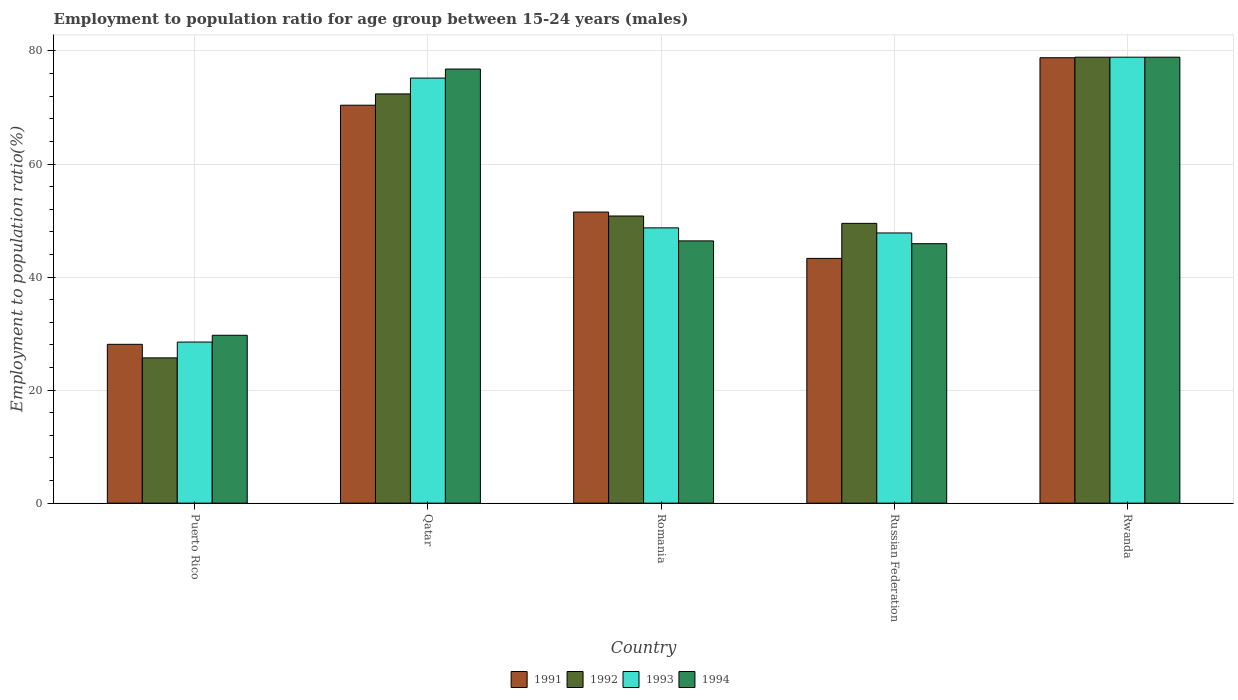How many different coloured bars are there?
Ensure brevity in your answer.  4. How many groups of bars are there?
Ensure brevity in your answer.  5. Are the number of bars per tick equal to the number of legend labels?
Offer a terse response. Yes. Are the number of bars on each tick of the X-axis equal?
Make the answer very short. Yes. How many bars are there on the 2nd tick from the right?
Give a very brief answer. 4. What is the label of the 4th group of bars from the left?
Ensure brevity in your answer.  Russian Federation. In how many cases, is the number of bars for a given country not equal to the number of legend labels?
Ensure brevity in your answer.  0. What is the employment to population ratio in 1991 in Russian Federation?
Ensure brevity in your answer.  43.3. Across all countries, what is the maximum employment to population ratio in 1994?
Offer a very short reply. 78.9. Across all countries, what is the minimum employment to population ratio in 1993?
Offer a very short reply. 28.5. In which country was the employment to population ratio in 1994 maximum?
Offer a very short reply. Rwanda. In which country was the employment to population ratio in 1992 minimum?
Give a very brief answer. Puerto Rico. What is the total employment to population ratio in 1992 in the graph?
Your answer should be very brief. 277.3. What is the difference between the employment to population ratio in 1992 in Russian Federation and that in Rwanda?
Offer a very short reply. -29.4. What is the difference between the employment to population ratio in 1994 in Romania and the employment to population ratio in 1992 in Russian Federation?
Ensure brevity in your answer.  -3.1. What is the average employment to population ratio in 1991 per country?
Provide a short and direct response. 54.42. What is the difference between the employment to population ratio of/in 1993 and employment to population ratio of/in 1994 in Qatar?
Offer a terse response. -1.6. What is the ratio of the employment to population ratio in 1991 in Puerto Rico to that in Romania?
Keep it short and to the point. 0.55. Is the employment to population ratio in 1992 in Romania less than that in Rwanda?
Your answer should be very brief. Yes. Is the difference between the employment to population ratio in 1993 in Qatar and Romania greater than the difference between the employment to population ratio in 1994 in Qatar and Romania?
Make the answer very short. No. What is the difference between the highest and the second highest employment to population ratio in 1993?
Make the answer very short. -26.5. What is the difference between the highest and the lowest employment to population ratio in 1991?
Ensure brevity in your answer.  50.7. Is it the case that in every country, the sum of the employment to population ratio in 1992 and employment to population ratio in 1993 is greater than the sum of employment to population ratio in 1994 and employment to population ratio in 1991?
Give a very brief answer. No. Is it the case that in every country, the sum of the employment to population ratio in 1992 and employment to population ratio in 1993 is greater than the employment to population ratio in 1994?
Make the answer very short. Yes. How many countries are there in the graph?
Keep it short and to the point. 5. What is the difference between two consecutive major ticks on the Y-axis?
Your response must be concise. 20. Are the values on the major ticks of Y-axis written in scientific E-notation?
Keep it short and to the point. No. How many legend labels are there?
Provide a succinct answer. 4. How are the legend labels stacked?
Your response must be concise. Horizontal. What is the title of the graph?
Offer a very short reply. Employment to population ratio for age group between 15-24 years (males). Does "1998" appear as one of the legend labels in the graph?
Offer a terse response. No. What is the label or title of the X-axis?
Keep it short and to the point. Country. What is the label or title of the Y-axis?
Ensure brevity in your answer.  Employment to population ratio(%). What is the Employment to population ratio(%) in 1991 in Puerto Rico?
Make the answer very short. 28.1. What is the Employment to population ratio(%) of 1992 in Puerto Rico?
Provide a succinct answer. 25.7. What is the Employment to population ratio(%) in 1993 in Puerto Rico?
Offer a very short reply. 28.5. What is the Employment to population ratio(%) of 1994 in Puerto Rico?
Give a very brief answer. 29.7. What is the Employment to population ratio(%) of 1991 in Qatar?
Offer a very short reply. 70.4. What is the Employment to population ratio(%) in 1992 in Qatar?
Keep it short and to the point. 72.4. What is the Employment to population ratio(%) in 1993 in Qatar?
Provide a succinct answer. 75.2. What is the Employment to population ratio(%) of 1994 in Qatar?
Your response must be concise. 76.8. What is the Employment to population ratio(%) of 1991 in Romania?
Offer a terse response. 51.5. What is the Employment to population ratio(%) of 1992 in Romania?
Make the answer very short. 50.8. What is the Employment to population ratio(%) in 1993 in Romania?
Your response must be concise. 48.7. What is the Employment to population ratio(%) of 1994 in Romania?
Offer a very short reply. 46.4. What is the Employment to population ratio(%) of 1991 in Russian Federation?
Offer a terse response. 43.3. What is the Employment to population ratio(%) in 1992 in Russian Federation?
Your answer should be compact. 49.5. What is the Employment to population ratio(%) in 1993 in Russian Federation?
Keep it short and to the point. 47.8. What is the Employment to population ratio(%) of 1994 in Russian Federation?
Keep it short and to the point. 45.9. What is the Employment to population ratio(%) in 1991 in Rwanda?
Offer a very short reply. 78.8. What is the Employment to population ratio(%) of 1992 in Rwanda?
Offer a terse response. 78.9. What is the Employment to population ratio(%) of 1993 in Rwanda?
Provide a succinct answer. 78.9. What is the Employment to population ratio(%) of 1994 in Rwanda?
Your answer should be very brief. 78.9. Across all countries, what is the maximum Employment to population ratio(%) of 1991?
Ensure brevity in your answer.  78.8. Across all countries, what is the maximum Employment to population ratio(%) in 1992?
Your answer should be very brief. 78.9. Across all countries, what is the maximum Employment to population ratio(%) of 1993?
Your answer should be very brief. 78.9. Across all countries, what is the maximum Employment to population ratio(%) of 1994?
Give a very brief answer. 78.9. Across all countries, what is the minimum Employment to population ratio(%) in 1991?
Ensure brevity in your answer.  28.1. Across all countries, what is the minimum Employment to population ratio(%) in 1992?
Your response must be concise. 25.7. Across all countries, what is the minimum Employment to population ratio(%) in 1993?
Your response must be concise. 28.5. Across all countries, what is the minimum Employment to population ratio(%) of 1994?
Your answer should be very brief. 29.7. What is the total Employment to population ratio(%) in 1991 in the graph?
Your answer should be compact. 272.1. What is the total Employment to population ratio(%) in 1992 in the graph?
Make the answer very short. 277.3. What is the total Employment to population ratio(%) in 1993 in the graph?
Give a very brief answer. 279.1. What is the total Employment to population ratio(%) of 1994 in the graph?
Offer a very short reply. 277.7. What is the difference between the Employment to population ratio(%) of 1991 in Puerto Rico and that in Qatar?
Your answer should be compact. -42.3. What is the difference between the Employment to population ratio(%) of 1992 in Puerto Rico and that in Qatar?
Offer a terse response. -46.7. What is the difference between the Employment to population ratio(%) of 1993 in Puerto Rico and that in Qatar?
Your answer should be compact. -46.7. What is the difference between the Employment to population ratio(%) of 1994 in Puerto Rico and that in Qatar?
Make the answer very short. -47.1. What is the difference between the Employment to population ratio(%) in 1991 in Puerto Rico and that in Romania?
Your answer should be compact. -23.4. What is the difference between the Employment to population ratio(%) of 1992 in Puerto Rico and that in Romania?
Give a very brief answer. -25.1. What is the difference between the Employment to population ratio(%) in 1993 in Puerto Rico and that in Romania?
Your answer should be compact. -20.2. What is the difference between the Employment to population ratio(%) of 1994 in Puerto Rico and that in Romania?
Offer a very short reply. -16.7. What is the difference between the Employment to population ratio(%) in 1991 in Puerto Rico and that in Russian Federation?
Ensure brevity in your answer.  -15.2. What is the difference between the Employment to population ratio(%) in 1992 in Puerto Rico and that in Russian Federation?
Your answer should be compact. -23.8. What is the difference between the Employment to population ratio(%) of 1993 in Puerto Rico and that in Russian Federation?
Your answer should be compact. -19.3. What is the difference between the Employment to population ratio(%) in 1994 in Puerto Rico and that in Russian Federation?
Your answer should be compact. -16.2. What is the difference between the Employment to population ratio(%) of 1991 in Puerto Rico and that in Rwanda?
Ensure brevity in your answer.  -50.7. What is the difference between the Employment to population ratio(%) of 1992 in Puerto Rico and that in Rwanda?
Give a very brief answer. -53.2. What is the difference between the Employment to population ratio(%) of 1993 in Puerto Rico and that in Rwanda?
Give a very brief answer. -50.4. What is the difference between the Employment to population ratio(%) in 1994 in Puerto Rico and that in Rwanda?
Make the answer very short. -49.2. What is the difference between the Employment to population ratio(%) of 1992 in Qatar and that in Romania?
Your answer should be compact. 21.6. What is the difference between the Employment to population ratio(%) of 1993 in Qatar and that in Romania?
Offer a very short reply. 26.5. What is the difference between the Employment to population ratio(%) of 1994 in Qatar and that in Romania?
Ensure brevity in your answer.  30.4. What is the difference between the Employment to population ratio(%) of 1991 in Qatar and that in Russian Federation?
Your answer should be very brief. 27.1. What is the difference between the Employment to population ratio(%) of 1992 in Qatar and that in Russian Federation?
Your answer should be very brief. 22.9. What is the difference between the Employment to population ratio(%) in 1993 in Qatar and that in Russian Federation?
Keep it short and to the point. 27.4. What is the difference between the Employment to population ratio(%) in 1994 in Qatar and that in Russian Federation?
Provide a succinct answer. 30.9. What is the difference between the Employment to population ratio(%) of 1991 in Romania and that in Rwanda?
Your response must be concise. -27.3. What is the difference between the Employment to population ratio(%) of 1992 in Romania and that in Rwanda?
Your answer should be very brief. -28.1. What is the difference between the Employment to population ratio(%) of 1993 in Romania and that in Rwanda?
Make the answer very short. -30.2. What is the difference between the Employment to population ratio(%) of 1994 in Romania and that in Rwanda?
Keep it short and to the point. -32.5. What is the difference between the Employment to population ratio(%) of 1991 in Russian Federation and that in Rwanda?
Ensure brevity in your answer.  -35.5. What is the difference between the Employment to population ratio(%) of 1992 in Russian Federation and that in Rwanda?
Offer a very short reply. -29.4. What is the difference between the Employment to population ratio(%) in 1993 in Russian Federation and that in Rwanda?
Your response must be concise. -31.1. What is the difference between the Employment to population ratio(%) of 1994 in Russian Federation and that in Rwanda?
Make the answer very short. -33. What is the difference between the Employment to population ratio(%) in 1991 in Puerto Rico and the Employment to population ratio(%) in 1992 in Qatar?
Give a very brief answer. -44.3. What is the difference between the Employment to population ratio(%) of 1991 in Puerto Rico and the Employment to population ratio(%) of 1993 in Qatar?
Offer a very short reply. -47.1. What is the difference between the Employment to population ratio(%) of 1991 in Puerto Rico and the Employment to population ratio(%) of 1994 in Qatar?
Provide a short and direct response. -48.7. What is the difference between the Employment to population ratio(%) in 1992 in Puerto Rico and the Employment to population ratio(%) in 1993 in Qatar?
Your answer should be compact. -49.5. What is the difference between the Employment to population ratio(%) in 1992 in Puerto Rico and the Employment to population ratio(%) in 1994 in Qatar?
Offer a very short reply. -51.1. What is the difference between the Employment to population ratio(%) of 1993 in Puerto Rico and the Employment to population ratio(%) of 1994 in Qatar?
Provide a succinct answer. -48.3. What is the difference between the Employment to population ratio(%) of 1991 in Puerto Rico and the Employment to population ratio(%) of 1992 in Romania?
Provide a succinct answer. -22.7. What is the difference between the Employment to population ratio(%) of 1991 in Puerto Rico and the Employment to population ratio(%) of 1993 in Romania?
Your answer should be compact. -20.6. What is the difference between the Employment to population ratio(%) in 1991 in Puerto Rico and the Employment to population ratio(%) in 1994 in Romania?
Your response must be concise. -18.3. What is the difference between the Employment to population ratio(%) in 1992 in Puerto Rico and the Employment to population ratio(%) in 1994 in Romania?
Keep it short and to the point. -20.7. What is the difference between the Employment to population ratio(%) of 1993 in Puerto Rico and the Employment to population ratio(%) of 1994 in Romania?
Give a very brief answer. -17.9. What is the difference between the Employment to population ratio(%) of 1991 in Puerto Rico and the Employment to population ratio(%) of 1992 in Russian Federation?
Keep it short and to the point. -21.4. What is the difference between the Employment to population ratio(%) in 1991 in Puerto Rico and the Employment to population ratio(%) in 1993 in Russian Federation?
Make the answer very short. -19.7. What is the difference between the Employment to population ratio(%) of 1991 in Puerto Rico and the Employment to population ratio(%) of 1994 in Russian Federation?
Give a very brief answer. -17.8. What is the difference between the Employment to population ratio(%) in 1992 in Puerto Rico and the Employment to population ratio(%) in 1993 in Russian Federation?
Give a very brief answer. -22.1. What is the difference between the Employment to population ratio(%) of 1992 in Puerto Rico and the Employment to population ratio(%) of 1994 in Russian Federation?
Your response must be concise. -20.2. What is the difference between the Employment to population ratio(%) of 1993 in Puerto Rico and the Employment to population ratio(%) of 1994 in Russian Federation?
Give a very brief answer. -17.4. What is the difference between the Employment to population ratio(%) in 1991 in Puerto Rico and the Employment to population ratio(%) in 1992 in Rwanda?
Your response must be concise. -50.8. What is the difference between the Employment to population ratio(%) in 1991 in Puerto Rico and the Employment to population ratio(%) in 1993 in Rwanda?
Your response must be concise. -50.8. What is the difference between the Employment to population ratio(%) of 1991 in Puerto Rico and the Employment to population ratio(%) of 1994 in Rwanda?
Offer a very short reply. -50.8. What is the difference between the Employment to population ratio(%) of 1992 in Puerto Rico and the Employment to population ratio(%) of 1993 in Rwanda?
Offer a terse response. -53.2. What is the difference between the Employment to population ratio(%) in 1992 in Puerto Rico and the Employment to population ratio(%) in 1994 in Rwanda?
Ensure brevity in your answer.  -53.2. What is the difference between the Employment to population ratio(%) of 1993 in Puerto Rico and the Employment to population ratio(%) of 1994 in Rwanda?
Provide a succinct answer. -50.4. What is the difference between the Employment to population ratio(%) in 1991 in Qatar and the Employment to population ratio(%) in 1992 in Romania?
Provide a short and direct response. 19.6. What is the difference between the Employment to population ratio(%) in 1991 in Qatar and the Employment to population ratio(%) in 1993 in Romania?
Your response must be concise. 21.7. What is the difference between the Employment to population ratio(%) of 1991 in Qatar and the Employment to population ratio(%) of 1994 in Romania?
Ensure brevity in your answer.  24. What is the difference between the Employment to population ratio(%) of 1992 in Qatar and the Employment to population ratio(%) of 1993 in Romania?
Your answer should be very brief. 23.7. What is the difference between the Employment to population ratio(%) in 1993 in Qatar and the Employment to population ratio(%) in 1994 in Romania?
Provide a short and direct response. 28.8. What is the difference between the Employment to population ratio(%) of 1991 in Qatar and the Employment to population ratio(%) of 1992 in Russian Federation?
Provide a succinct answer. 20.9. What is the difference between the Employment to population ratio(%) of 1991 in Qatar and the Employment to population ratio(%) of 1993 in Russian Federation?
Keep it short and to the point. 22.6. What is the difference between the Employment to population ratio(%) in 1991 in Qatar and the Employment to population ratio(%) in 1994 in Russian Federation?
Your answer should be very brief. 24.5. What is the difference between the Employment to population ratio(%) in 1992 in Qatar and the Employment to population ratio(%) in 1993 in Russian Federation?
Ensure brevity in your answer.  24.6. What is the difference between the Employment to population ratio(%) of 1993 in Qatar and the Employment to population ratio(%) of 1994 in Russian Federation?
Provide a short and direct response. 29.3. What is the difference between the Employment to population ratio(%) in 1991 in Qatar and the Employment to population ratio(%) in 1992 in Rwanda?
Offer a very short reply. -8.5. What is the difference between the Employment to population ratio(%) in 1991 in Qatar and the Employment to population ratio(%) in 1993 in Rwanda?
Your answer should be very brief. -8.5. What is the difference between the Employment to population ratio(%) in 1992 in Qatar and the Employment to population ratio(%) in 1993 in Rwanda?
Ensure brevity in your answer.  -6.5. What is the difference between the Employment to population ratio(%) in 1992 in Qatar and the Employment to population ratio(%) in 1994 in Rwanda?
Provide a succinct answer. -6.5. What is the difference between the Employment to population ratio(%) of 1993 in Qatar and the Employment to population ratio(%) of 1994 in Rwanda?
Your response must be concise. -3.7. What is the difference between the Employment to population ratio(%) in 1991 in Romania and the Employment to population ratio(%) in 1992 in Rwanda?
Provide a succinct answer. -27.4. What is the difference between the Employment to population ratio(%) of 1991 in Romania and the Employment to population ratio(%) of 1993 in Rwanda?
Offer a terse response. -27.4. What is the difference between the Employment to population ratio(%) of 1991 in Romania and the Employment to population ratio(%) of 1994 in Rwanda?
Your answer should be very brief. -27.4. What is the difference between the Employment to population ratio(%) of 1992 in Romania and the Employment to population ratio(%) of 1993 in Rwanda?
Keep it short and to the point. -28.1. What is the difference between the Employment to population ratio(%) in 1992 in Romania and the Employment to population ratio(%) in 1994 in Rwanda?
Your answer should be compact. -28.1. What is the difference between the Employment to population ratio(%) of 1993 in Romania and the Employment to population ratio(%) of 1994 in Rwanda?
Offer a terse response. -30.2. What is the difference between the Employment to population ratio(%) of 1991 in Russian Federation and the Employment to population ratio(%) of 1992 in Rwanda?
Offer a terse response. -35.6. What is the difference between the Employment to population ratio(%) in 1991 in Russian Federation and the Employment to population ratio(%) in 1993 in Rwanda?
Offer a very short reply. -35.6. What is the difference between the Employment to population ratio(%) in 1991 in Russian Federation and the Employment to population ratio(%) in 1994 in Rwanda?
Your answer should be compact. -35.6. What is the difference between the Employment to population ratio(%) of 1992 in Russian Federation and the Employment to population ratio(%) of 1993 in Rwanda?
Ensure brevity in your answer.  -29.4. What is the difference between the Employment to population ratio(%) of 1992 in Russian Federation and the Employment to population ratio(%) of 1994 in Rwanda?
Offer a very short reply. -29.4. What is the difference between the Employment to population ratio(%) of 1993 in Russian Federation and the Employment to population ratio(%) of 1994 in Rwanda?
Ensure brevity in your answer.  -31.1. What is the average Employment to population ratio(%) in 1991 per country?
Your answer should be very brief. 54.42. What is the average Employment to population ratio(%) in 1992 per country?
Your answer should be compact. 55.46. What is the average Employment to population ratio(%) of 1993 per country?
Your answer should be compact. 55.82. What is the average Employment to population ratio(%) in 1994 per country?
Provide a short and direct response. 55.54. What is the difference between the Employment to population ratio(%) of 1992 and Employment to population ratio(%) of 1994 in Puerto Rico?
Ensure brevity in your answer.  -4. What is the difference between the Employment to population ratio(%) in 1991 and Employment to population ratio(%) in 1992 in Qatar?
Give a very brief answer. -2. What is the difference between the Employment to population ratio(%) of 1991 and Employment to population ratio(%) of 1993 in Qatar?
Your answer should be compact. -4.8. What is the difference between the Employment to population ratio(%) of 1992 and Employment to population ratio(%) of 1994 in Qatar?
Keep it short and to the point. -4.4. What is the difference between the Employment to population ratio(%) of 1991 and Employment to population ratio(%) of 1992 in Romania?
Your response must be concise. 0.7. What is the difference between the Employment to population ratio(%) of 1991 and Employment to population ratio(%) of 1993 in Romania?
Give a very brief answer. 2.8. What is the difference between the Employment to population ratio(%) in 1992 and Employment to population ratio(%) in 1993 in Romania?
Ensure brevity in your answer.  2.1. What is the difference between the Employment to population ratio(%) in 1992 and Employment to population ratio(%) in 1994 in Russian Federation?
Your response must be concise. 3.6. What is the difference between the Employment to population ratio(%) in 1993 and Employment to population ratio(%) in 1994 in Russian Federation?
Provide a short and direct response. 1.9. What is the difference between the Employment to population ratio(%) in 1991 and Employment to population ratio(%) in 1992 in Rwanda?
Your answer should be compact. -0.1. What is the difference between the Employment to population ratio(%) in 1992 and Employment to population ratio(%) in 1993 in Rwanda?
Provide a succinct answer. 0. What is the difference between the Employment to population ratio(%) of 1992 and Employment to population ratio(%) of 1994 in Rwanda?
Offer a terse response. 0. What is the difference between the Employment to population ratio(%) in 1993 and Employment to population ratio(%) in 1994 in Rwanda?
Offer a terse response. 0. What is the ratio of the Employment to population ratio(%) in 1991 in Puerto Rico to that in Qatar?
Your response must be concise. 0.4. What is the ratio of the Employment to population ratio(%) of 1992 in Puerto Rico to that in Qatar?
Ensure brevity in your answer.  0.35. What is the ratio of the Employment to population ratio(%) in 1993 in Puerto Rico to that in Qatar?
Make the answer very short. 0.38. What is the ratio of the Employment to population ratio(%) of 1994 in Puerto Rico to that in Qatar?
Your answer should be very brief. 0.39. What is the ratio of the Employment to population ratio(%) of 1991 in Puerto Rico to that in Romania?
Make the answer very short. 0.55. What is the ratio of the Employment to population ratio(%) in 1992 in Puerto Rico to that in Romania?
Offer a terse response. 0.51. What is the ratio of the Employment to population ratio(%) in 1993 in Puerto Rico to that in Romania?
Ensure brevity in your answer.  0.59. What is the ratio of the Employment to population ratio(%) of 1994 in Puerto Rico to that in Romania?
Your answer should be compact. 0.64. What is the ratio of the Employment to population ratio(%) of 1991 in Puerto Rico to that in Russian Federation?
Give a very brief answer. 0.65. What is the ratio of the Employment to population ratio(%) of 1992 in Puerto Rico to that in Russian Federation?
Offer a terse response. 0.52. What is the ratio of the Employment to population ratio(%) in 1993 in Puerto Rico to that in Russian Federation?
Ensure brevity in your answer.  0.6. What is the ratio of the Employment to population ratio(%) of 1994 in Puerto Rico to that in Russian Federation?
Your response must be concise. 0.65. What is the ratio of the Employment to population ratio(%) in 1991 in Puerto Rico to that in Rwanda?
Provide a short and direct response. 0.36. What is the ratio of the Employment to population ratio(%) in 1992 in Puerto Rico to that in Rwanda?
Ensure brevity in your answer.  0.33. What is the ratio of the Employment to population ratio(%) in 1993 in Puerto Rico to that in Rwanda?
Ensure brevity in your answer.  0.36. What is the ratio of the Employment to population ratio(%) of 1994 in Puerto Rico to that in Rwanda?
Provide a succinct answer. 0.38. What is the ratio of the Employment to population ratio(%) in 1991 in Qatar to that in Romania?
Offer a very short reply. 1.37. What is the ratio of the Employment to population ratio(%) of 1992 in Qatar to that in Romania?
Ensure brevity in your answer.  1.43. What is the ratio of the Employment to population ratio(%) in 1993 in Qatar to that in Romania?
Your response must be concise. 1.54. What is the ratio of the Employment to population ratio(%) in 1994 in Qatar to that in Romania?
Ensure brevity in your answer.  1.66. What is the ratio of the Employment to population ratio(%) in 1991 in Qatar to that in Russian Federation?
Provide a short and direct response. 1.63. What is the ratio of the Employment to population ratio(%) of 1992 in Qatar to that in Russian Federation?
Offer a very short reply. 1.46. What is the ratio of the Employment to population ratio(%) of 1993 in Qatar to that in Russian Federation?
Your answer should be very brief. 1.57. What is the ratio of the Employment to population ratio(%) of 1994 in Qatar to that in Russian Federation?
Keep it short and to the point. 1.67. What is the ratio of the Employment to population ratio(%) of 1991 in Qatar to that in Rwanda?
Your answer should be compact. 0.89. What is the ratio of the Employment to population ratio(%) of 1992 in Qatar to that in Rwanda?
Keep it short and to the point. 0.92. What is the ratio of the Employment to population ratio(%) in 1993 in Qatar to that in Rwanda?
Ensure brevity in your answer.  0.95. What is the ratio of the Employment to population ratio(%) in 1994 in Qatar to that in Rwanda?
Offer a very short reply. 0.97. What is the ratio of the Employment to population ratio(%) in 1991 in Romania to that in Russian Federation?
Your answer should be compact. 1.19. What is the ratio of the Employment to population ratio(%) of 1992 in Romania to that in Russian Federation?
Provide a short and direct response. 1.03. What is the ratio of the Employment to population ratio(%) in 1993 in Romania to that in Russian Federation?
Offer a very short reply. 1.02. What is the ratio of the Employment to population ratio(%) of 1994 in Romania to that in Russian Federation?
Offer a terse response. 1.01. What is the ratio of the Employment to population ratio(%) in 1991 in Romania to that in Rwanda?
Your answer should be very brief. 0.65. What is the ratio of the Employment to population ratio(%) in 1992 in Romania to that in Rwanda?
Your answer should be compact. 0.64. What is the ratio of the Employment to population ratio(%) in 1993 in Romania to that in Rwanda?
Make the answer very short. 0.62. What is the ratio of the Employment to population ratio(%) in 1994 in Romania to that in Rwanda?
Keep it short and to the point. 0.59. What is the ratio of the Employment to population ratio(%) in 1991 in Russian Federation to that in Rwanda?
Give a very brief answer. 0.55. What is the ratio of the Employment to population ratio(%) in 1992 in Russian Federation to that in Rwanda?
Your answer should be very brief. 0.63. What is the ratio of the Employment to population ratio(%) of 1993 in Russian Federation to that in Rwanda?
Provide a succinct answer. 0.61. What is the ratio of the Employment to population ratio(%) in 1994 in Russian Federation to that in Rwanda?
Ensure brevity in your answer.  0.58. What is the difference between the highest and the second highest Employment to population ratio(%) in 1994?
Ensure brevity in your answer.  2.1. What is the difference between the highest and the lowest Employment to population ratio(%) of 1991?
Give a very brief answer. 50.7. What is the difference between the highest and the lowest Employment to population ratio(%) in 1992?
Offer a terse response. 53.2. What is the difference between the highest and the lowest Employment to population ratio(%) of 1993?
Your response must be concise. 50.4. What is the difference between the highest and the lowest Employment to population ratio(%) in 1994?
Offer a terse response. 49.2. 